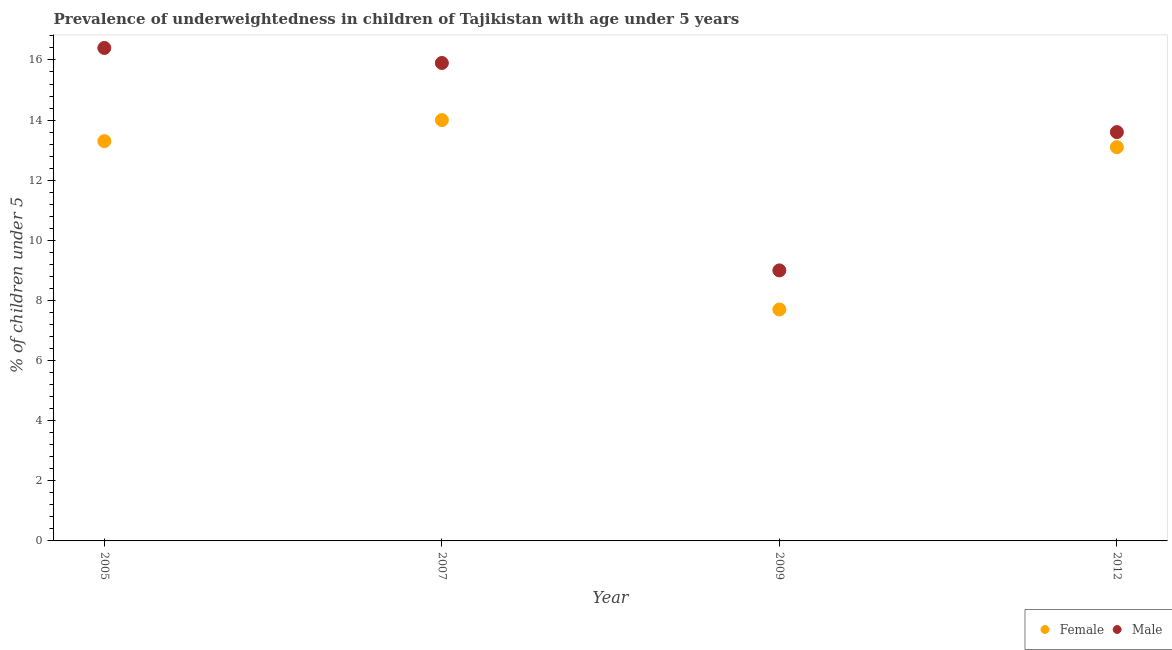Is the number of dotlines equal to the number of legend labels?
Make the answer very short. Yes. What is the percentage of underweighted female children in 2012?
Provide a short and direct response. 13.1. Across all years, what is the maximum percentage of underweighted female children?
Ensure brevity in your answer.  14. Across all years, what is the minimum percentage of underweighted male children?
Ensure brevity in your answer.  9. In which year was the percentage of underweighted female children maximum?
Ensure brevity in your answer.  2007. What is the total percentage of underweighted female children in the graph?
Your answer should be compact. 48.1. What is the difference between the percentage of underweighted female children in 2007 and that in 2012?
Give a very brief answer. 0.9. What is the difference between the percentage of underweighted female children in 2012 and the percentage of underweighted male children in 2009?
Your answer should be compact. 4.1. What is the average percentage of underweighted male children per year?
Provide a succinct answer. 13.72. What is the ratio of the percentage of underweighted female children in 2005 to that in 2007?
Keep it short and to the point. 0.95. Is the difference between the percentage of underweighted male children in 2009 and 2012 greater than the difference between the percentage of underweighted female children in 2009 and 2012?
Your answer should be very brief. Yes. What is the difference between the highest and the second highest percentage of underweighted male children?
Give a very brief answer. 0.5. What is the difference between the highest and the lowest percentage of underweighted female children?
Provide a succinct answer. 6.3. In how many years, is the percentage of underweighted female children greater than the average percentage of underweighted female children taken over all years?
Make the answer very short. 3. Does the percentage of underweighted female children monotonically increase over the years?
Your answer should be compact. No. Is the percentage of underweighted female children strictly greater than the percentage of underweighted male children over the years?
Offer a very short reply. No. How many dotlines are there?
Provide a short and direct response. 2. How many years are there in the graph?
Provide a short and direct response. 4. Where does the legend appear in the graph?
Ensure brevity in your answer.  Bottom right. What is the title of the graph?
Keep it short and to the point. Prevalence of underweightedness in children of Tajikistan with age under 5 years. What is the label or title of the Y-axis?
Your answer should be very brief.  % of children under 5. What is the  % of children under 5 of Female in 2005?
Give a very brief answer. 13.3. What is the  % of children under 5 of Male in 2005?
Offer a terse response. 16.4. What is the  % of children under 5 of Male in 2007?
Your answer should be very brief. 15.9. What is the  % of children under 5 of Female in 2009?
Offer a terse response. 7.7. What is the  % of children under 5 in Male in 2009?
Give a very brief answer. 9. What is the  % of children under 5 in Female in 2012?
Provide a succinct answer. 13.1. What is the  % of children under 5 in Male in 2012?
Your answer should be very brief. 13.6. Across all years, what is the maximum  % of children under 5 in Male?
Offer a terse response. 16.4. Across all years, what is the minimum  % of children under 5 of Female?
Provide a succinct answer. 7.7. What is the total  % of children under 5 in Female in the graph?
Provide a short and direct response. 48.1. What is the total  % of children under 5 in Male in the graph?
Offer a very short reply. 54.9. What is the difference between the  % of children under 5 in Female in 2005 and that in 2007?
Your response must be concise. -0.7. What is the difference between the  % of children under 5 in Male in 2005 and that in 2007?
Keep it short and to the point. 0.5. What is the difference between the  % of children under 5 of Female in 2005 and that in 2009?
Offer a very short reply. 5.6. What is the difference between the  % of children under 5 of Male in 2005 and that in 2009?
Ensure brevity in your answer.  7.4. What is the difference between the  % of children under 5 in Female in 2005 and that in 2012?
Provide a short and direct response. 0.2. What is the difference between the  % of children under 5 of Female in 2007 and that in 2009?
Provide a short and direct response. 6.3. What is the difference between the  % of children under 5 in Male in 2007 and that in 2012?
Provide a short and direct response. 2.3. What is the difference between the  % of children under 5 in Male in 2009 and that in 2012?
Your response must be concise. -4.6. What is the difference between the  % of children under 5 in Female in 2005 and the  % of children under 5 in Male in 2007?
Your answer should be very brief. -2.6. What is the difference between the  % of children under 5 in Female in 2005 and the  % of children under 5 in Male in 2012?
Offer a terse response. -0.3. What is the difference between the  % of children under 5 in Female in 2007 and the  % of children under 5 in Male in 2009?
Your answer should be compact. 5. What is the difference between the  % of children under 5 of Female in 2007 and the  % of children under 5 of Male in 2012?
Your response must be concise. 0.4. What is the difference between the  % of children under 5 in Female in 2009 and the  % of children under 5 in Male in 2012?
Offer a very short reply. -5.9. What is the average  % of children under 5 of Female per year?
Your answer should be very brief. 12.03. What is the average  % of children under 5 of Male per year?
Make the answer very short. 13.72. In the year 2007, what is the difference between the  % of children under 5 in Female and  % of children under 5 in Male?
Your answer should be compact. -1.9. In the year 2009, what is the difference between the  % of children under 5 of Female and  % of children under 5 of Male?
Your answer should be compact. -1.3. What is the ratio of the  % of children under 5 in Male in 2005 to that in 2007?
Your answer should be very brief. 1.03. What is the ratio of the  % of children under 5 in Female in 2005 to that in 2009?
Provide a succinct answer. 1.73. What is the ratio of the  % of children under 5 of Male in 2005 to that in 2009?
Provide a succinct answer. 1.82. What is the ratio of the  % of children under 5 in Female in 2005 to that in 2012?
Make the answer very short. 1.02. What is the ratio of the  % of children under 5 of Male in 2005 to that in 2012?
Offer a very short reply. 1.21. What is the ratio of the  % of children under 5 in Female in 2007 to that in 2009?
Offer a very short reply. 1.82. What is the ratio of the  % of children under 5 in Male in 2007 to that in 2009?
Your answer should be compact. 1.77. What is the ratio of the  % of children under 5 in Female in 2007 to that in 2012?
Your response must be concise. 1.07. What is the ratio of the  % of children under 5 in Male in 2007 to that in 2012?
Give a very brief answer. 1.17. What is the ratio of the  % of children under 5 in Female in 2009 to that in 2012?
Offer a very short reply. 0.59. What is the ratio of the  % of children under 5 in Male in 2009 to that in 2012?
Your answer should be compact. 0.66. What is the difference between the highest and the second highest  % of children under 5 of Female?
Ensure brevity in your answer.  0.7. What is the difference between the highest and the second highest  % of children under 5 in Male?
Your answer should be very brief. 0.5. 